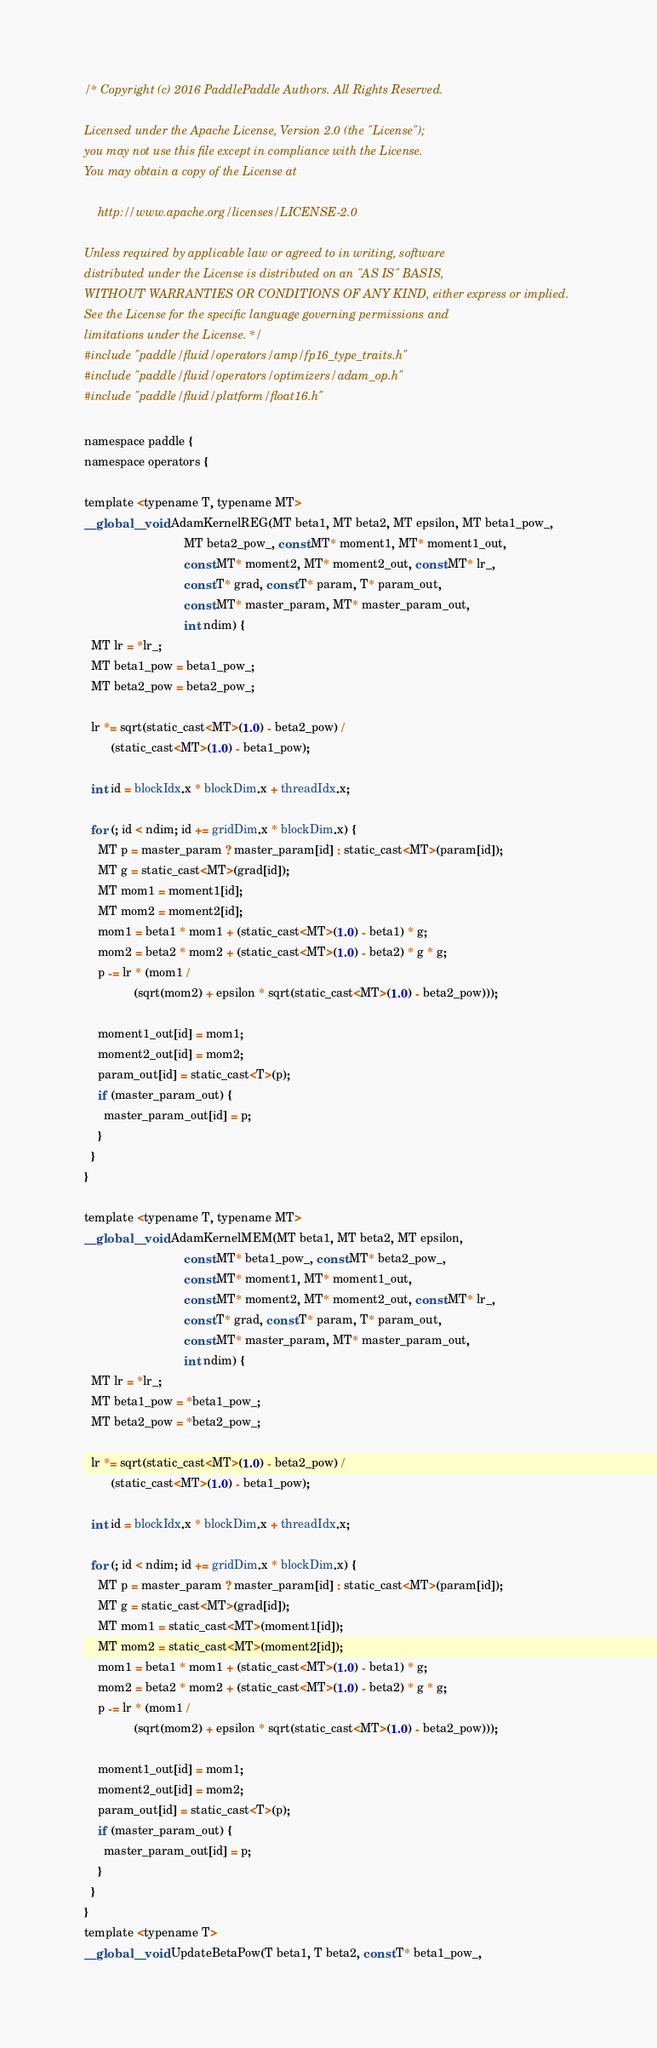Convert code to text. <code><loc_0><loc_0><loc_500><loc_500><_Cuda_>/* Copyright (c) 2016 PaddlePaddle Authors. All Rights Reserved.

Licensed under the Apache License, Version 2.0 (the "License");
you may not use this file except in compliance with the License.
You may obtain a copy of the License at

    http://www.apache.org/licenses/LICENSE-2.0

Unless required by applicable law or agreed to in writing, software
distributed under the License is distributed on an "AS IS" BASIS,
WITHOUT WARRANTIES OR CONDITIONS OF ANY KIND, either express or implied.
See the License for the specific language governing permissions and
limitations under the License. */
#include "paddle/fluid/operators/amp/fp16_type_traits.h"
#include "paddle/fluid/operators/optimizers/adam_op.h"
#include "paddle/fluid/platform/float16.h"

namespace paddle {
namespace operators {

template <typename T, typename MT>
__global__ void AdamKernelREG(MT beta1, MT beta2, MT epsilon, MT beta1_pow_,
                              MT beta2_pow_, const MT* moment1, MT* moment1_out,
                              const MT* moment2, MT* moment2_out, const MT* lr_,
                              const T* grad, const T* param, T* param_out,
                              const MT* master_param, MT* master_param_out,
                              int ndim) {
  MT lr = *lr_;
  MT beta1_pow = beta1_pow_;
  MT beta2_pow = beta2_pow_;

  lr *= sqrt(static_cast<MT>(1.0) - beta2_pow) /
        (static_cast<MT>(1.0) - beta1_pow);

  int id = blockIdx.x * blockDim.x + threadIdx.x;

  for (; id < ndim; id += gridDim.x * blockDim.x) {
    MT p = master_param ? master_param[id] : static_cast<MT>(param[id]);
    MT g = static_cast<MT>(grad[id]);
    MT mom1 = moment1[id];
    MT mom2 = moment2[id];
    mom1 = beta1 * mom1 + (static_cast<MT>(1.0) - beta1) * g;
    mom2 = beta2 * mom2 + (static_cast<MT>(1.0) - beta2) * g * g;
    p -= lr * (mom1 /
               (sqrt(mom2) + epsilon * sqrt(static_cast<MT>(1.0) - beta2_pow)));

    moment1_out[id] = mom1;
    moment2_out[id] = mom2;
    param_out[id] = static_cast<T>(p);
    if (master_param_out) {
      master_param_out[id] = p;
    }
  }
}

template <typename T, typename MT>
__global__ void AdamKernelMEM(MT beta1, MT beta2, MT epsilon,
                              const MT* beta1_pow_, const MT* beta2_pow_,
                              const MT* moment1, MT* moment1_out,
                              const MT* moment2, MT* moment2_out, const MT* lr_,
                              const T* grad, const T* param, T* param_out,
                              const MT* master_param, MT* master_param_out,
                              int ndim) {
  MT lr = *lr_;
  MT beta1_pow = *beta1_pow_;
  MT beta2_pow = *beta2_pow_;

  lr *= sqrt(static_cast<MT>(1.0) - beta2_pow) /
        (static_cast<MT>(1.0) - beta1_pow);

  int id = blockIdx.x * blockDim.x + threadIdx.x;

  for (; id < ndim; id += gridDim.x * blockDim.x) {
    MT p = master_param ? master_param[id] : static_cast<MT>(param[id]);
    MT g = static_cast<MT>(grad[id]);
    MT mom1 = static_cast<MT>(moment1[id]);
    MT mom2 = static_cast<MT>(moment2[id]);
    mom1 = beta1 * mom1 + (static_cast<MT>(1.0) - beta1) * g;
    mom2 = beta2 * mom2 + (static_cast<MT>(1.0) - beta2) * g * g;
    p -= lr * (mom1 /
               (sqrt(mom2) + epsilon * sqrt(static_cast<MT>(1.0) - beta2_pow)));

    moment1_out[id] = mom1;
    moment2_out[id] = mom2;
    param_out[id] = static_cast<T>(p);
    if (master_param_out) {
      master_param_out[id] = p;
    }
  }
}
template <typename T>
__global__ void UpdateBetaPow(T beta1, T beta2, const T* beta1_pow_,</code> 